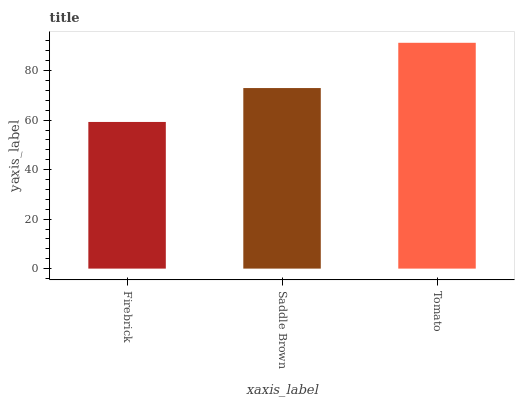Is Firebrick the minimum?
Answer yes or no. Yes. Is Tomato the maximum?
Answer yes or no. Yes. Is Saddle Brown the minimum?
Answer yes or no. No. Is Saddle Brown the maximum?
Answer yes or no. No. Is Saddle Brown greater than Firebrick?
Answer yes or no. Yes. Is Firebrick less than Saddle Brown?
Answer yes or no. Yes. Is Firebrick greater than Saddle Brown?
Answer yes or no. No. Is Saddle Brown less than Firebrick?
Answer yes or no. No. Is Saddle Brown the high median?
Answer yes or no. Yes. Is Saddle Brown the low median?
Answer yes or no. Yes. Is Tomato the high median?
Answer yes or no. No. Is Tomato the low median?
Answer yes or no. No. 